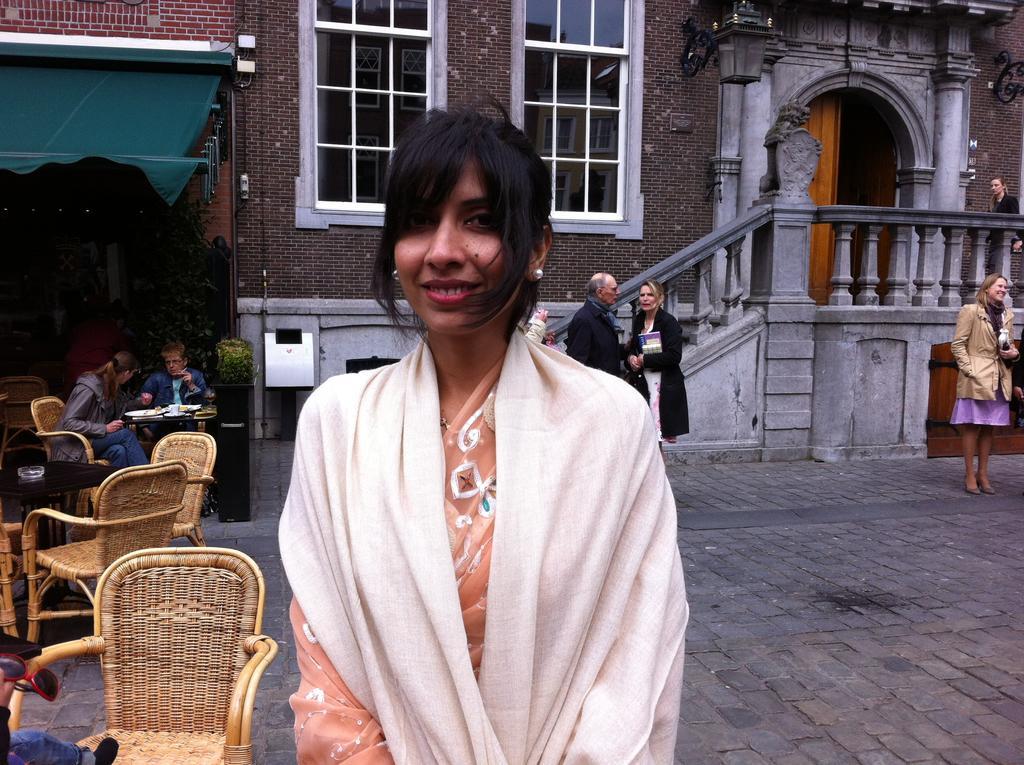Please provide a concise description of this image. This image consists of a woman wearing a white color cloth. To the left, there are chairs. In the background, there are buildings along with windows. At the bottom, there is a road. 